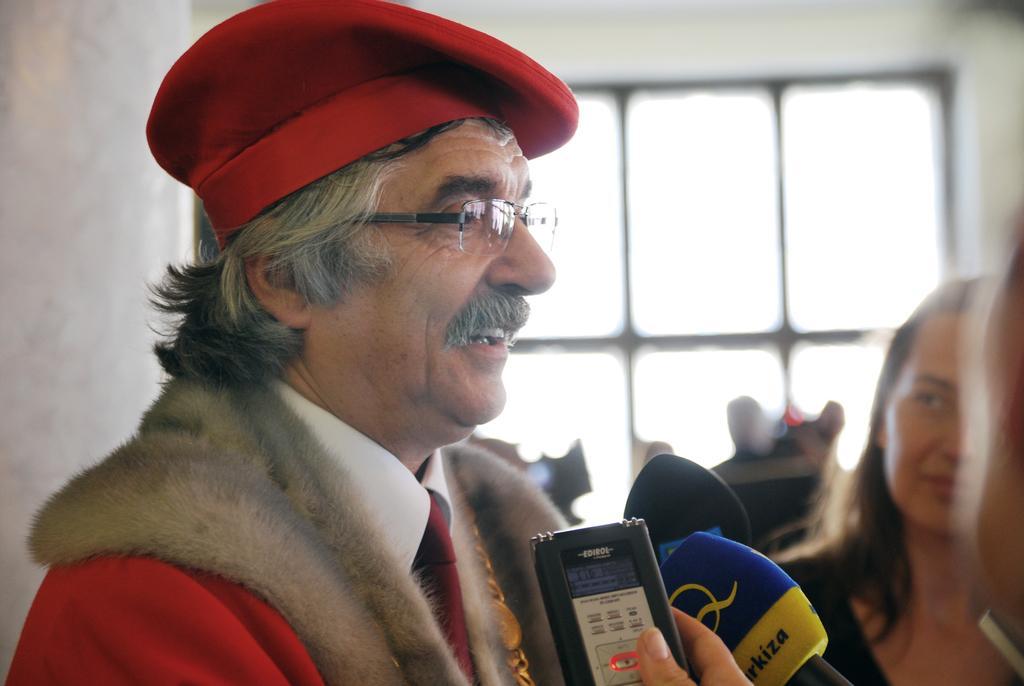In one or two sentences, can you explain what this image depicts? In this image I can see a group of people on the floor, some objects and mike. In the background I can see a wall and glass window. This image is taken may be in a hall. 